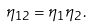<formula> <loc_0><loc_0><loc_500><loc_500>\eta _ { 1 2 } = \eta _ { 1 } \eta _ { 2 } .</formula> 